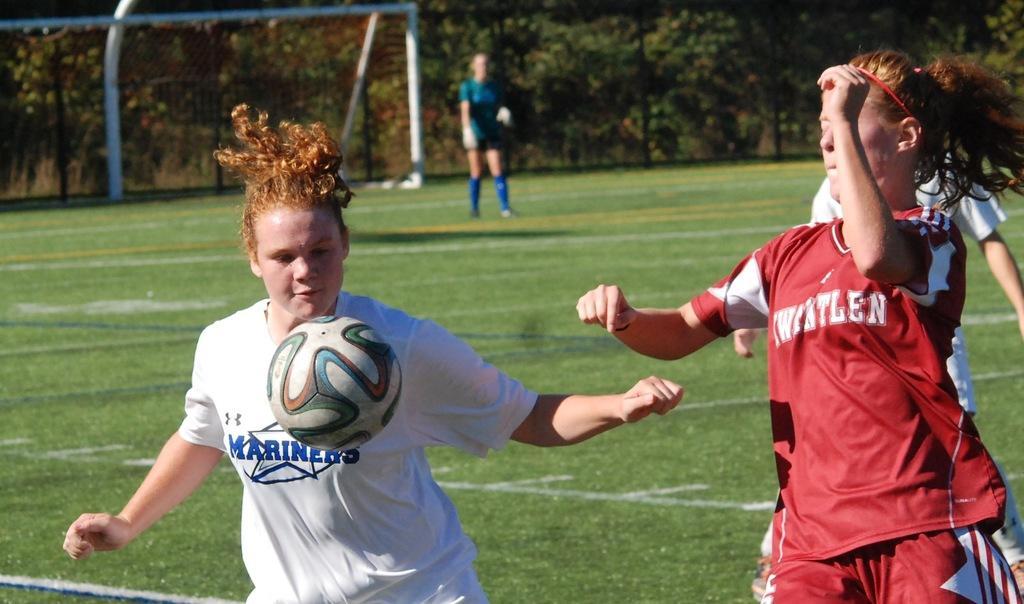Please provide a concise description of this image. In the center of the image we can see three people playing football. On the left there is a ball. In the background there is a lady standing and we can see a net. There are trees. 